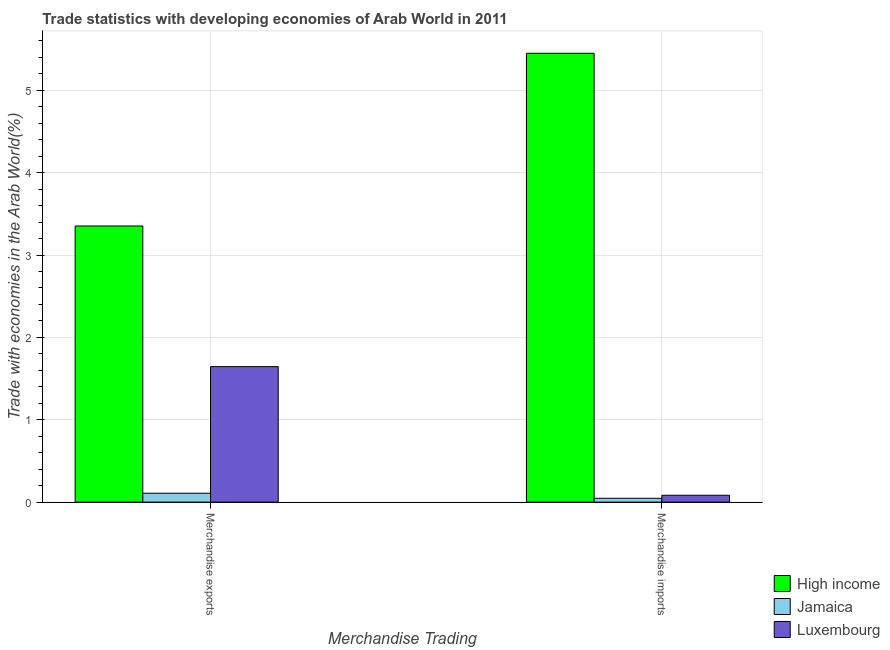How many different coloured bars are there?
Offer a very short reply. 3. Are the number of bars per tick equal to the number of legend labels?
Make the answer very short. Yes. Are the number of bars on each tick of the X-axis equal?
Make the answer very short. Yes. How many bars are there on the 2nd tick from the left?
Ensure brevity in your answer.  3. What is the label of the 1st group of bars from the left?
Make the answer very short. Merchandise exports. What is the merchandise imports in Jamaica?
Your answer should be compact. 0.05. Across all countries, what is the maximum merchandise imports?
Provide a succinct answer. 5.45. Across all countries, what is the minimum merchandise exports?
Offer a very short reply. 0.11. In which country was the merchandise exports minimum?
Provide a short and direct response. Jamaica. What is the total merchandise exports in the graph?
Make the answer very short. 5.11. What is the difference between the merchandise imports in Luxembourg and that in High income?
Provide a succinct answer. -5.37. What is the difference between the merchandise exports in Jamaica and the merchandise imports in High income?
Make the answer very short. -5.34. What is the average merchandise imports per country?
Your answer should be compact. 1.86. What is the difference between the merchandise imports and merchandise exports in Luxembourg?
Your answer should be very brief. -1.56. In how many countries, is the merchandise imports greater than 3.2 %?
Offer a very short reply. 1. What is the ratio of the merchandise imports in Jamaica to that in Luxembourg?
Your response must be concise. 0.56. Is the merchandise exports in Luxembourg less than that in High income?
Give a very brief answer. Yes. What does the 1st bar from the left in Merchandise imports represents?
Give a very brief answer. High income. Are all the bars in the graph horizontal?
Ensure brevity in your answer.  No. How many countries are there in the graph?
Offer a terse response. 3. What is the difference between two consecutive major ticks on the Y-axis?
Your answer should be very brief. 1. Are the values on the major ticks of Y-axis written in scientific E-notation?
Your answer should be compact. No. Does the graph contain any zero values?
Ensure brevity in your answer.  No. Where does the legend appear in the graph?
Keep it short and to the point. Bottom right. How many legend labels are there?
Keep it short and to the point. 3. What is the title of the graph?
Provide a succinct answer. Trade statistics with developing economies of Arab World in 2011. Does "Trinidad and Tobago" appear as one of the legend labels in the graph?
Your answer should be very brief. No. What is the label or title of the X-axis?
Make the answer very short. Merchandise Trading. What is the label or title of the Y-axis?
Your answer should be very brief. Trade with economies in the Arab World(%). What is the Trade with economies in the Arab World(%) in High income in Merchandise exports?
Provide a short and direct response. 3.35. What is the Trade with economies in the Arab World(%) of Jamaica in Merchandise exports?
Your response must be concise. 0.11. What is the Trade with economies in the Arab World(%) of Luxembourg in Merchandise exports?
Ensure brevity in your answer.  1.65. What is the Trade with economies in the Arab World(%) of High income in Merchandise imports?
Give a very brief answer. 5.45. What is the Trade with economies in the Arab World(%) in Jamaica in Merchandise imports?
Your answer should be compact. 0.05. What is the Trade with economies in the Arab World(%) of Luxembourg in Merchandise imports?
Make the answer very short. 0.08. Across all Merchandise Trading, what is the maximum Trade with economies in the Arab World(%) in High income?
Your response must be concise. 5.45. Across all Merchandise Trading, what is the maximum Trade with economies in the Arab World(%) of Jamaica?
Your response must be concise. 0.11. Across all Merchandise Trading, what is the maximum Trade with economies in the Arab World(%) of Luxembourg?
Make the answer very short. 1.65. Across all Merchandise Trading, what is the minimum Trade with economies in the Arab World(%) in High income?
Give a very brief answer. 3.35. Across all Merchandise Trading, what is the minimum Trade with economies in the Arab World(%) of Jamaica?
Offer a terse response. 0.05. Across all Merchandise Trading, what is the minimum Trade with economies in the Arab World(%) of Luxembourg?
Your answer should be very brief. 0.08. What is the total Trade with economies in the Arab World(%) of High income in the graph?
Offer a terse response. 8.8. What is the total Trade with economies in the Arab World(%) in Jamaica in the graph?
Provide a succinct answer. 0.15. What is the total Trade with economies in the Arab World(%) in Luxembourg in the graph?
Offer a terse response. 1.73. What is the difference between the Trade with economies in the Arab World(%) of High income in Merchandise exports and that in Merchandise imports?
Give a very brief answer. -2.1. What is the difference between the Trade with economies in the Arab World(%) of Jamaica in Merchandise exports and that in Merchandise imports?
Your answer should be very brief. 0.06. What is the difference between the Trade with economies in the Arab World(%) of Luxembourg in Merchandise exports and that in Merchandise imports?
Your response must be concise. 1.56. What is the difference between the Trade with economies in the Arab World(%) in High income in Merchandise exports and the Trade with economies in the Arab World(%) in Jamaica in Merchandise imports?
Make the answer very short. 3.31. What is the difference between the Trade with economies in the Arab World(%) in High income in Merchandise exports and the Trade with economies in the Arab World(%) in Luxembourg in Merchandise imports?
Keep it short and to the point. 3.27. What is the difference between the Trade with economies in the Arab World(%) of Jamaica in Merchandise exports and the Trade with economies in the Arab World(%) of Luxembourg in Merchandise imports?
Keep it short and to the point. 0.02. What is the average Trade with economies in the Arab World(%) in High income per Merchandise Trading?
Provide a short and direct response. 4.4. What is the average Trade with economies in the Arab World(%) in Jamaica per Merchandise Trading?
Give a very brief answer. 0.08. What is the average Trade with economies in the Arab World(%) of Luxembourg per Merchandise Trading?
Provide a succinct answer. 0.86. What is the difference between the Trade with economies in the Arab World(%) in High income and Trade with economies in the Arab World(%) in Jamaica in Merchandise exports?
Provide a succinct answer. 3.24. What is the difference between the Trade with economies in the Arab World(%) in High income and Trade with economies in the Arab World(%) in Luxembourg in Merchandise exports?
Offer a terse response. 1.71. What is the difference between the Trade with economies in the Arab World(%) in Jamaica and Trade with economies in the Arab World(%) in Luxembourg in Merchandise exports?
Your answer should be very brief. -1.54. What is the difference between the Trade with economies in the Arab World(%) of High income and Trade with economies in the Arab World(%) of Jamaica in Merchandise imports?
Your answer should be compact. 5.4. What is the difference between the Trade with economies in the Arab World(%) in High income and Trade with economies in the Arab World(%) in Luxembourg in Merchandise imports?
Offer a very short reply. 5.37. What is the difference between the Trade with economies in the Arab World(%) in Jamaica and Trade with economies in the Arab World(%) in Luxembourg in Merchandise imports?
Make the answer very short. -0.04. What is the ratio of the Trade with economies in the Arab World(%) in High income in Merchandise exports to that in Merchandise imports?
Ensure brevity in your answer.  0.62. What is the ratio of the Trade with economies in the Arab World(%) in Jamaica in Merchandise exports to that in Merchandise imports?
Your answer should be compact. 2.32. What is the ratio of the Trade with economies in the Arab World(%) in Luxembourg in Merchandise exports to that in Merchandise imports?
Give a very brief answer. 19.75. What is the difference between the highest and the second highest Trade with economies in the Arab World(%) of High income?
Offer a very short reply. 2.1. What is the difference between the highest and the second highest Trade with economies in the Arab World(%) in Jamaica?
Make the answer very short. 0.06. What is the difference between the highest and the second highest Trade with economies in the Arab World(%) of Luxembourg?
Your answer should be compact. 1.56. What is the difference between the highest and the lowest Trade with economies in the Arab World(%) of High income?
Keep it short and to the point. 2.1. What is the difference between the highest and the lowest Trade with economies in the Arab World(%) in Jamaica?
Keep it short and to the point. 0.06. What is the difference between the highest and the lowest Trade with economies in the Arab World(%) of Luxembourg?
Provide a succinct answer. 1.56. 